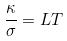Convert formula to latex. <formula><loc_0><loc_0><loc_500><loc_500>\frac { \kappa } { \sigma } = L T</formula> 